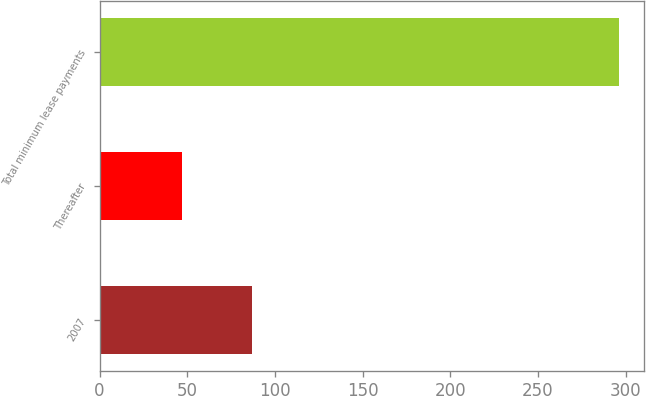Convert chart to OTSL. <chart><loc_0><loc_0><loc_500><loc_500><bar_chart><fcel>2007<fcel>Thereafter<fcel>Total minimum lease payments<nl><fcel>87<fcel>47<fcel>296<nl></chart> 